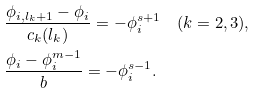Convert formula to latex. <formula><loc_0><loc_0><loc_500><loc_500>& \frac { \phi _ { i , l _ { k } + 1 } - \phi _ { i } } { c _ { k } ( l _ { k } ) } = - \phi _ { i } ^ { s + 1 } \quad ( k = 2 , 3 ) , \\ & \frac { \phi _ { i } - \phi _ { i } ^ { m - 1 } } { b } = - \phi _ { i } ^ { s - 1 } .</formula> 